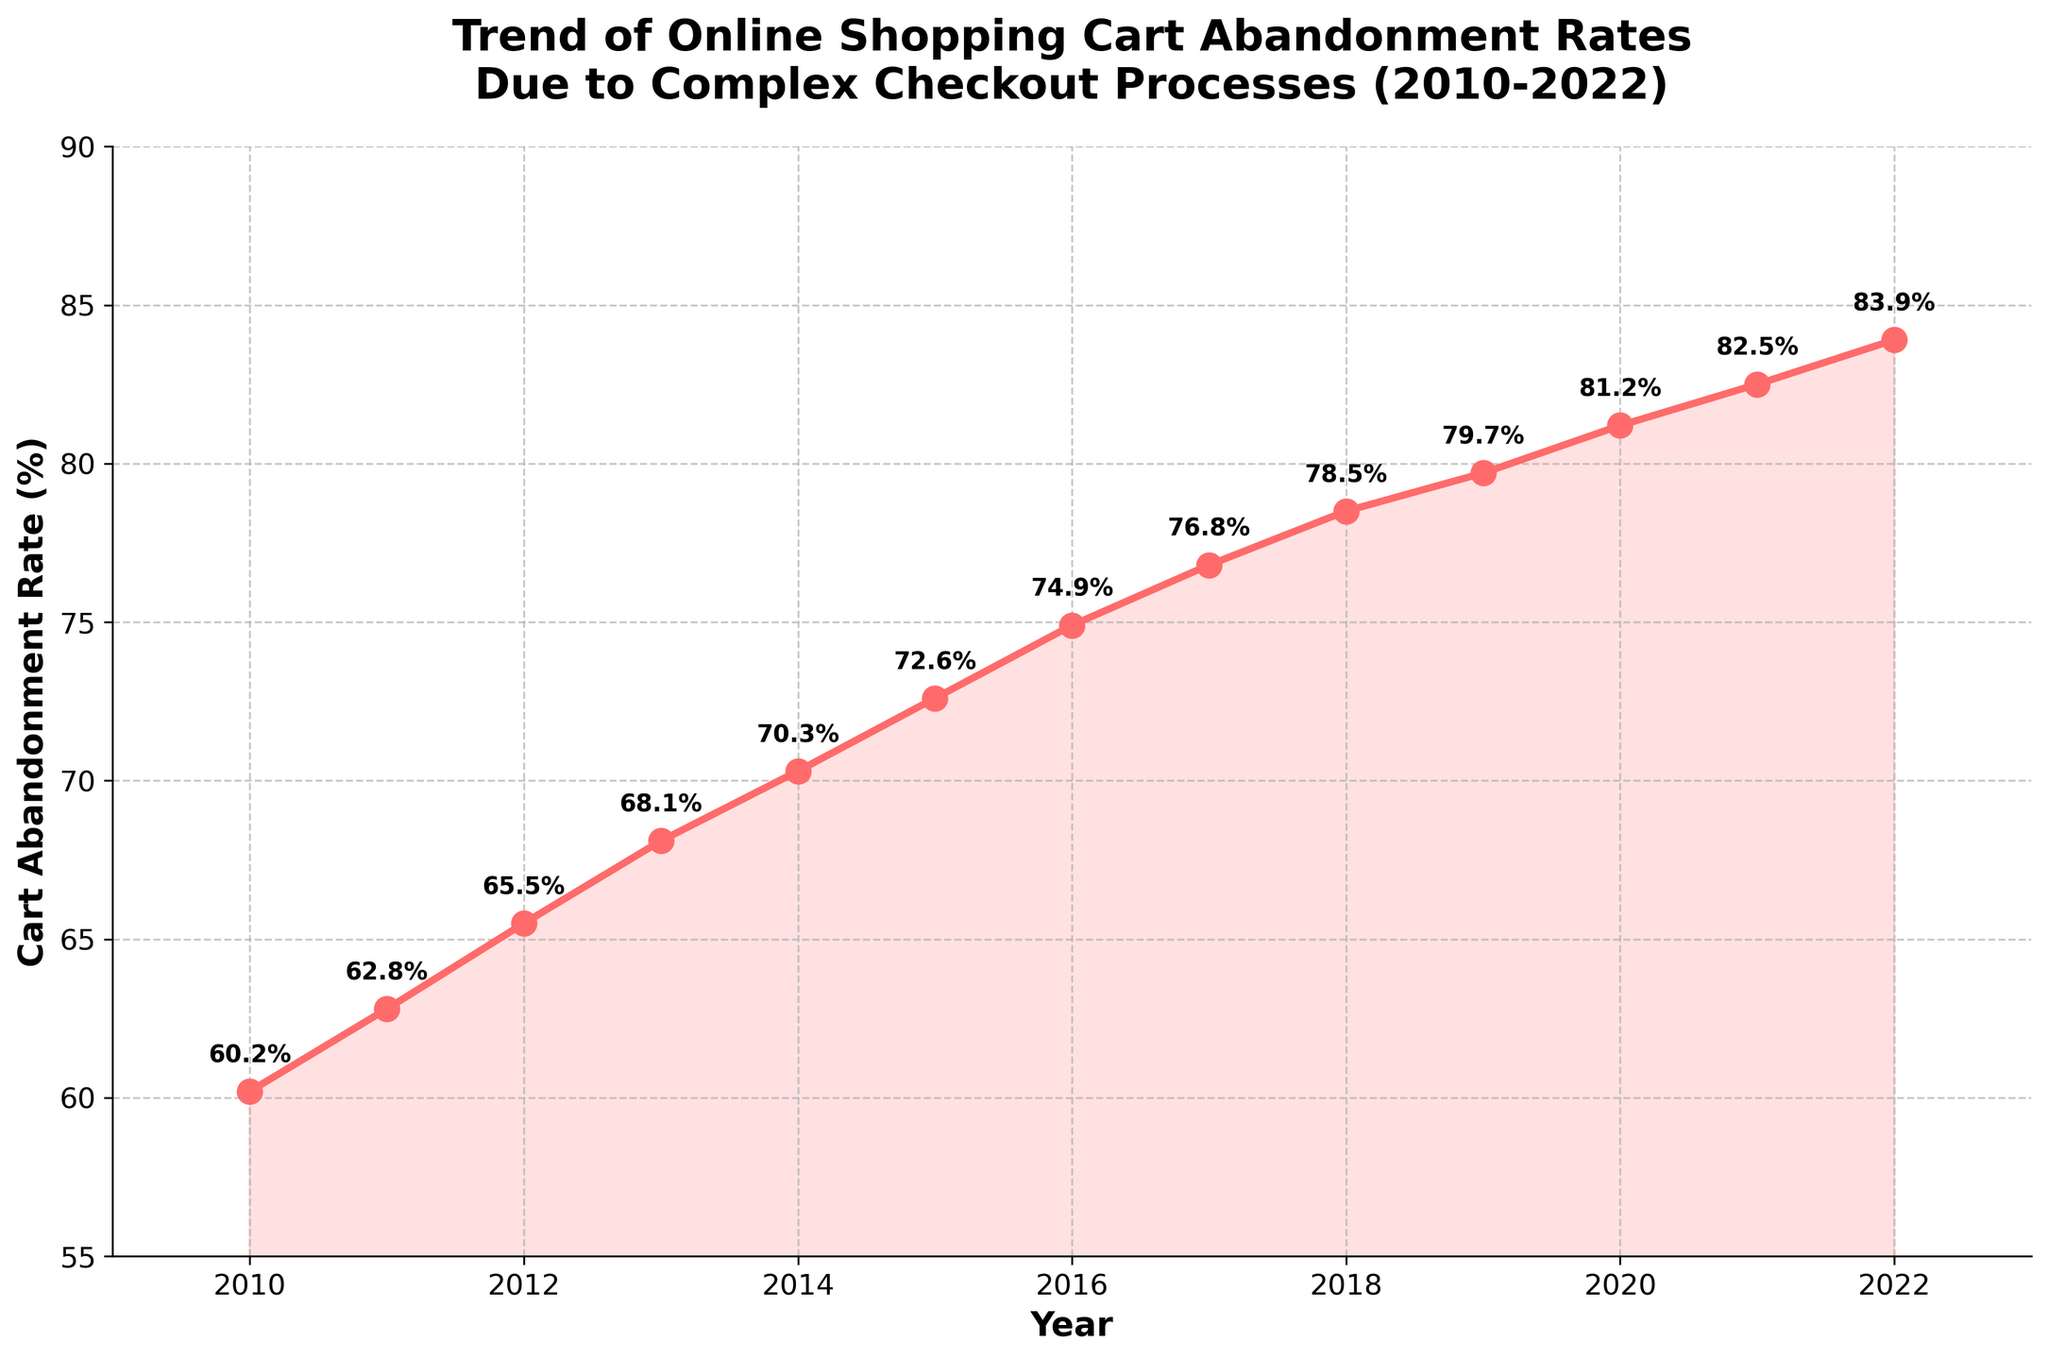What is the trend in the cart abandonment rate from 2010 to 2022? The cart abandonment rate shows a clear increasing trend from 60.2% in 2010 to 83.9% in 2022.
Answer: Increasing By how much did the cart abandonment rate increase from 2010 to 2022? The cart abandonment rate increased by (83.9 - 60.2)%.
Answer: 23.7% Which year observed the highest cart abandonment rate? Looking at the highest point on the graph, the highest cart abandonment rate of 83.9% is observed in 2022.
Answer: 2022 How does the rate of increase in cart abandonment between 2010 and 2016 compare to that between 2016 and 2022? From 2010 to 2016, the rate increased from 60.2% to 74.9% (14.7%). From 2016 to 2022, it increased from 74.9% to 83.9% (9%). So, the increase was more significant from 2010 to 2016.
Answer: The increase was more significant from 2010 to 2016 Was there any year where the rate remained constant or decreased compared to the previous year? No, the rate increased every year consistently from 2010 to 2022.
Answer: No Describe the visual appearance of the line plot used for cart abandonment rates. The plot uses a solid red line with circular markers at each data point and a shaded area below the line. The axes are labeled, and annotations of the rates appear at each point.
Answer: Red line with markers and shaded area 